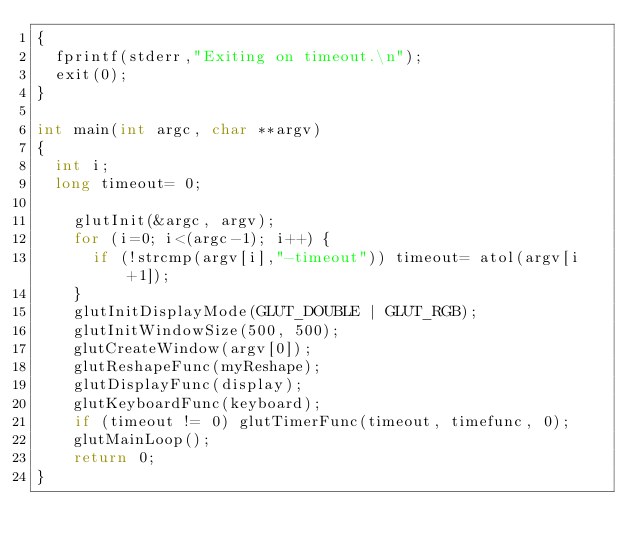<code> <loc_0><loc_0><loc_500><loc_500><_C_>{
  fprintf(stderr,"Exiting on timeout.\n");
  exit(0);
}

int main(int argc, char **argv)
{
  int i;
  long timeout= 0;

    glutInit(&argc, argv);
    for (i=0; i<(argc-1); i++) {
      if (!strcmp(argv[i],"-timeout")) timeout= atol(argv[i+1]);
    }
    glutInitDisplayMode(GLUT_DOUBLE | GLUT_RGB);
    glutInitWindowSize(500, 500);
    glutCreateWindow(argv[0]);
    glutReshapeFunc(myReshape);
    glutDisplayFunc(display);
    glutKeyboardFunc(keyboard);
    if (timeout != 0) glutTimerFunc(timeout, timefunc, 0);
    glutMainLoop();
    return 0;
}
</code> 